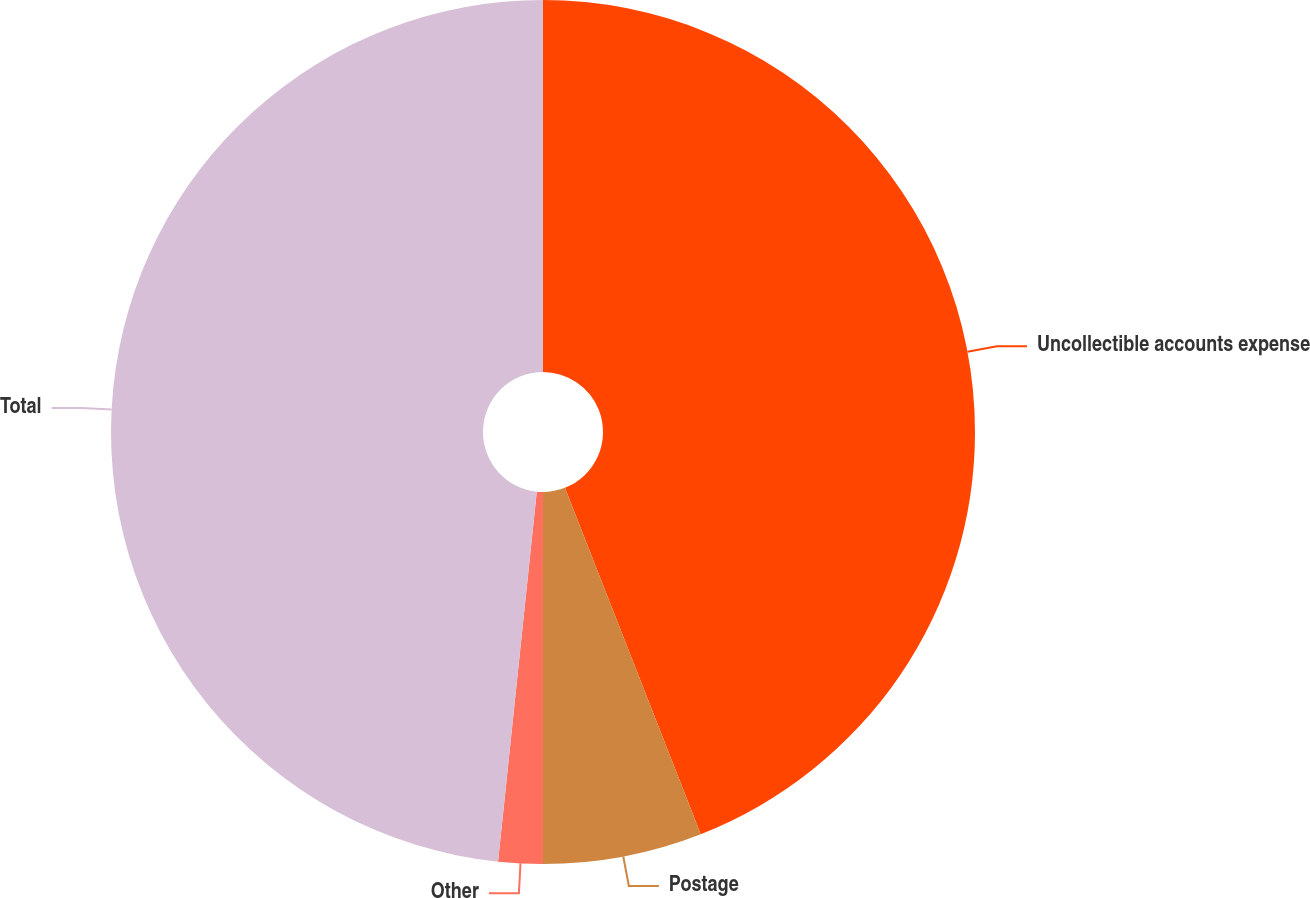<chart> <loc_0><loc_0><loc_500><loc_500><pie_chart><fcel>Uncollectible accounts expense<fcel>Postage<fcel>Other<fcel>Total<nl><fcel>44.05%<fcel>5.95%<fcel>1.66%<fcel>48.34%<nl></chart> 